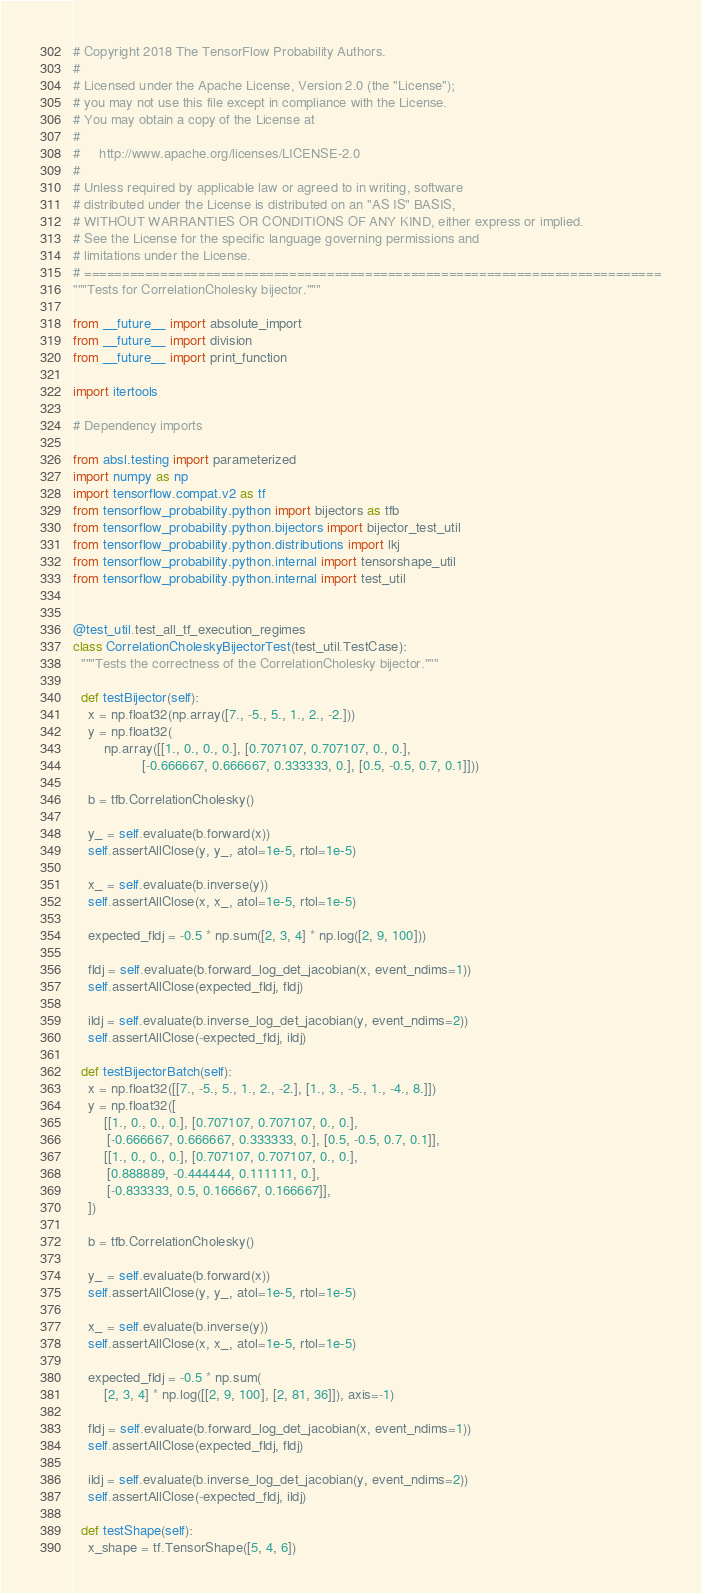<code> <loc_0><loc_0><loc_500><loc_500><_Python_># Copyright 2018 The TensorFlow Probability Authors.
#
# Licensed under the Apache License, Version 2.0 (the "License");
# you may not use this file except in compliance with the License.
# You may obtain a copy of the License at
#
#     http://www.apache.org/licenses/LICENSE-2.0
#
# Unless required by applicable law or agreed to in writing, software
# distributed under the License is distributed on an "AS IS" BASIS,
# WITHOUT WARRANTIES OR CONDITIONS OF ANY KIND, either express or implied.
# See the License for the specific language governing permissions and
# limitations under the License.
# ============================================================================
"""Tests for CorrelationCholesky bijector."""

from __future__ import absolute_import
from __future__ import division
from __future__ import print_function

import itertools

# Dependency imports

from absl.testing import parameterized
import numpy as np
import tensorflow.compat.v2 as tf
from tensorflow_probability.python import bijectors as tfb
from tensorflow_probability.python.bijectors import bijector_test_util
from tensorflow_probability.python.distributions import lkj
from tensorflow_probability.python.internal import tensorshape_util
from tensorflow_probability.python.internal import test_util


@test_util.test_all_tf_execution_regimes
class CorrelationCholeskyBijectorTest(test_util.TestCase):
  """Tests the correctness of the CorrelationCholesky bijector."""

  def testBijector(self):
    x = np.float32(np.array([7., -5., 5., 1., 2., -2.]))
    y = np.float32(
        np.array([[1., 0., 0., 0.], [0.707107, 0.707107, 0., 0.],
                  [-0.666667, 0.666667, 0.333333, 0.], [0.5, -0.5, 0.7, 0.1]]))

    b = tfb.CorrelationCholesky()

    y_ = self.evaluate(b.forward(x))
    self.assertAllClose(y, y_, atol=1e-5, rtol=1e-5)

    x_ = self.evaluate(b.inverse(y))
    self.assertAllClose(x, x_, atol=1e-5, rtol=1e-5)

    expected_fldj = -0.5 * np.sum([2, 3, 4] * np.log([2, 9, 100]))

    fldj = self.evaluate(b.forward_log_det_jacobian(x, event_ndims=1))
    self.assertAllClose(expected_fldj, fldj)

    ildj = self.evaluate(b.inverse_log_det_jacobian(y, event_ndims=2))
    self.assertAllClose(-expected_fldj, ildj)

  def testBijectorBatch(self):
    x = np.float32([[7., -5., 5., 1., 2., -2.], [1., 3., -5., 1., -4., 8.]])
    y = np.float32([
        [[1., 0., 0., 0.], [0.707107, 0.707107, 0., 0.],
         [-0.666667, 0.666667, 0.333333, 0.], [0.5, -0.5, 0.7, 0.1]],
        [[1., 0., 0., 0.], [0.707107, 0.707107, 0., 0.],
         [0.888889, -0.444444, 0.111111, 0.],
         [-0.833333, 0.5, 0.166667, 0.166667]],
    ])

    b = tfb.CorrelationCholesky()

    y_ = self.evaluate(b.forward(x))
    self.assertAllClose(y, y_, atol=1e-5, rtol=1e-5)

    x_ = self.evaluate(b.inverse(y))
    self.assertAllClose(x, x_, atol=1e-5, rtol=1e-5)

    expected_fldj = -0.5 * np.sum(
        [2, 3, 4] * np.log([[2, 9, 100], [2, 81, 36]]), axis=-1)

    fldj = self.evaluate(b.forward_log_det_jacobian(x, event_ndims=1))
    self.assertAllClose(expected_fldj, fldj)

    ildj = self.evaluate(b.inverse_log_det_jacobian(y, event_ndims=2))
    self.assertAllClose(-expected_fldj, ildj)

  def testShape(self):
    x_shape = tf.TensorShape([5, 4, 6])</code> 